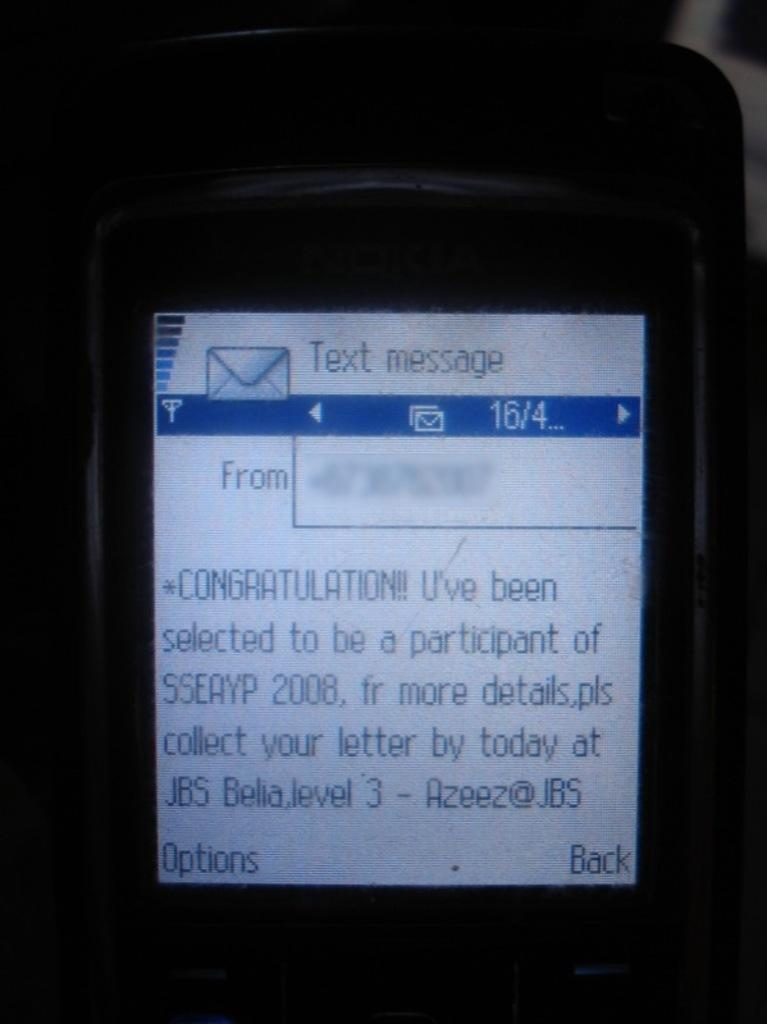<image>
Create a compact narrative representing the image presented. A cell phone is open to a message that says Congratulations. 